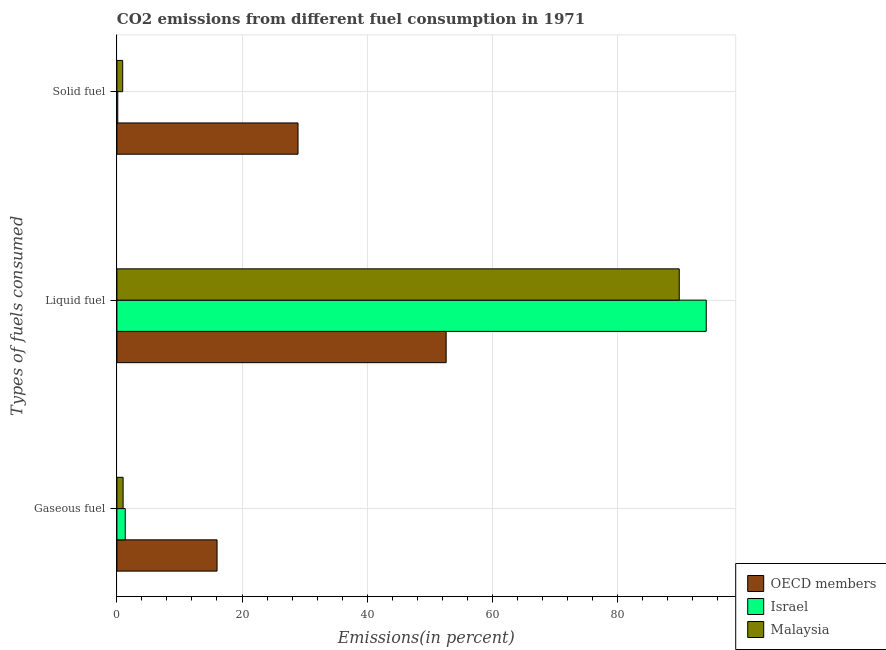How many different coloured bars are there?
Make the answer very short. 3. How many groups of bars are there?
Make the answer very short. 3. What is the label of the 3rd group of bars from the top?
Provide a short and direct response. Gaseous fuel. What is the percentage of gaseous fuel emission in Malaysia?
Keep it short and to the point. 0.99. Across all countries, what is the maximum percentage of gaseous fuel emission?
Ensure brevity in your answer.  16.01. Across all countries, what is the minimum percentage of gaseous fuel emission?
Offer a very short reply. 0.99. In which country was the percentage of liquid fuel emission maximum?
Give a very brief answer. Israel. In which country was the percentage of liquid fuel emission minimum?
Your answer should be very brief. OECD members. What is the total percentage of solid fuel emission in the graph?
Your answer should be compact. 30.01. What is the difference between the percentage of solid fuel emission in Malaysia and that in OECD members?
Provide a succinct answer. -28.03. What is the difference between the percentage of gaseous fuel emission in Malaysia and the percentage of solid fuel emission in Israel?
Ensure brevity in your answer.  0.85. What is the average percentage of liquid fuel emission per country?
Your response must be concise. 78.92. What is the difference between the percentage of solid fuel emission and percentage of liquid fuel emission in Malaysia?
Keep it short and to the point. -88.98. What is the ratio of the percentage of liquid fuel emission in Israel to that in Malaysia?
Your answer should be very brief. 1.05. Is the percentage of liquid fuel emission in OECD members less than that in Israel?
Ensure brevity in your answer.  Yes. Is the difference between the percentage of liquid fuel emission in OECD members and Israel greater than the difference between the percentage of gaseous fuel emission in OECD members and Israel?
Give a very brief answer. No. What is the difference between the highest and the second highest percentage of solid fuel emission?
Ensure brevity in your answer.  28.03. What is the difference between the highest and the lowest percentage of liquid fuel emission?
Your response must be concise. 41.58. In how many countries, is the percentage of solid fuel emission greater than the average percentage of solid fuel emission taken over all countries?
Give a very brief answer. 1. What does the 3rd bar from the bottom in Liquid fuel represents?
Your response must be concise. Malaysia. How many bars are there?
Your response must be concise. 9. Are all the bars in the graph horizontal?
Ensure brevity in your answer.  Yes. Are the values on the major ticks of X-axis written in scientific E-notation?
Offer a terse response. No. Does the graph contain any zero values?
Offer a very short reply. No. Does the graph contain grids?
Your answer should be compact. Yes. What is the title of the graph?
Make the answer very short. CO2 emissions from different fuel consumption in 1971. Does "Finland" appear as one of the legend labels in the graph?
Your answer should be very brief. No. What is the label or title of the X-axis?
Ensure brevity in your answer.  Emissions(in percent). What is the label or title of the Y-axis?
Offer a terse response. Types of fuels consumed. What is the Emissions(in percent) of OECD members in Gaseous fuel?
Your response must be concise. 16.01. What is the Emissions(in percent) in Israel in Gaseous fuel?
Offer a terse response. 1.33. What is the Emissions(in percent) of Malaysia in Gaseous fuel?
Provide a short and direct response. 0.99. What is the Emissions(in percent) of OECD members in Liquid fuel?
Offer a terse response. 52.64. What is the Emissions(in percent) of Israel in Liquid fuel?
Your answer should be very brief. 94.22. What is the Emissions(in percent) in Malaysia in Liquid fuel?
Offer a very short reply. 89.91. What is the Emissions(in percent) of OECD members in Solid fuel?
Your answer should be compact. 28.95. What is the Emissions(in percent) in Israel in Solid fuel?
Make the answer very short. 0.14. What is the Emissions(in percent) of Malaysia in Solid fuel?
Provide a short and direct response. 0.92. Across all Types of fuels consumed, what is the maximum Emissions(in percent) of OECD members?
Your answer should be compact. 52.64. Across all Types of fuels consumed, what is the maximum Emissions(in percent) in Israel?
Make the answer very short. 94.22. Across all Types of fuels consumed, what is the maximum Emissions(in percent) in Malaysia?
Your response must be concise. 89.91. Across all Types of fuels consumed, what is the minimum Emissions(in percent) in OECD members?
Keep it short and to the point. 16.01. Across all Types of fuels consumed, what is the minimum Emissions(in percent) of Israel?
Provide a succinct answer. 0.14. Across all Types of fuels consumed, what is the minimum Emissions(in percent) in Malaysia?
Ensure brevity in your answer.  0.92. What is the total Emissions(in percent) in OECD members in the graph?
Your response must be concise. 97.6. What is the total Emissions(in percent) of Israel in the graph?
Keep it short and to the point. 95.69. What is the total Emissions(in percent) of Malaysia in the graph?
Provide a short and direct response. 91.82. What is the difference between the Emissions(in percent) of OECD members in Gaseous fuel and that in Liquid fuel?
Your response must be concise. -36.63. What is the difference between the Emissions(in percent) in Israel in Gaseous fuel and that in Liquid fuel?
Make the answer very short. -92.89. What is the difference between the Emissions(in percent) of Malaysia in Gaseous fuel and that in Liquid fuel?
Provide a succinct answer. -88.92. What is the difference between the Emissions(in percent) in OECD members in Gaseous fuel and that in Solid fuel?
Offer a terse response. -12.95. What is the difference between the Emissions(in percent) of Israel in Gaseous fuel and that in Solid fuel?
Your response must be concise. 1.2. What is the difference between the Emissions(in percent) of Malaysia in Gaseous fuel and that in Solid fuel?
Make the answer very short. 0.07. What is the difference between the Emissions(in percent) in OECD members in Liquid fuel and that in Solid fuel?
Offer a terse response. 23.68. What is the difference between the Emissions(in percent) of Israel in Liquid fuel and that in Solid fuel?
Your response must be concise. 94.09. What is the difference between the Emissions(in percent) of Malaysia in Liquid fuel and that in Solid fuel?
Offer a terse response. 88.98. What is the difference between the Emissions(in percent) in OECD members in Gaseous fuel and the Emissions(in percent) in Israel in Liquid fuel?
Offer a terse response. -78.21. What is the difference between the Emissions(in percent) in OECD members in Gaseous fuel and the Emissions(in percent) in Malaysia in Liquid fuel?
Keep it short and to the point. -73.9. What is the difference between the Emissions(in percent) in Israel in Gaseous fuel and the Emissions(in percent) in Malaysia in Liquid fuel?
Provide a succinct answer. -88.58. What is the difference between the Emissions(in percent) in OECD members in Gaseous fuel and the Emissions(in percent) in Israel in Solid fuel?
Your answer should be very brief. 15.87. What is the difference between the Emissions(in percent) in OECD members in Gaseous fuel and the Emissions(in percent) in Malaysia in Solid fuel?
Make the answer very short. 15.09. What is the difference between the Emissions(in percent) in Israel in Gaseous fuel and the Emissions(in percent) in Malaysia in Solid fuel?
Keep it short and to the point. 0.41. What is the difference between the Emissions(in percent) in OECD members in Liquid fuel and the Emissions(in percent) in Israel in Solid fuel?
Offer a very short reply. 52.5. What is the difference between the Emissions(in percent) in OECD members in Liquid fuel and the Emissions(in percent) in Malaysia in Solid fuel?
Keep it short and to the point. 51.71. What is the difference between the Emissions(in percent) of Israel in Liquid fuel and the Emissions(in percent) of Malaysia in Solid fuel?
Provide a succinct answer. 93.3. What is the average Emissions(in percent) of OECD members per Types of fuels consumed?
Offer a very short reply. 32.53. What is the average Emissions(in percent) of Israel per Types of fuels consumed?
Provide a succinct answer. 31.9. What is the average Emissions(in percent) of Malaysia per Types of fuels consumed?
Your answer should be compact. 30.61. What is the difference between the Emissions(in percent) of OECD members and Emissions(in percent) of Israel in Gaseous fuel?
Offer a very short reply. 14.68. What is the difference between the Emissions(in percent) of OECD members and Emissions(in percent) of Malaysia in Gaseous fuel?
Provide a short and direct response. 15.02. What is the difference between the Emissions(in percent) in Israel and Emissions(in percent) in Malaysia in Gaseous fuel?
Offer a very short reply. 0.34. What is the difference between the Emissions(in percent) of OECD members and Emissions(in percent) of Israel in Liquid fuel?
Give a very brief answer. -41.58. What is the difference between the Emissions(in percent) in OECD members and Emissions(in percent) in Malaysia in Liquid fuel?
Your answer should be compact. -37.27. What is the difference between the Emissions(in percent) in Israel and Emissions(in percent) in Malaysia in Liquid fuel?
Give a very brief answer. 4.31. What is the difference between the Emissions(in percent) of OECD members and Emissions(in percent) of Israel in Solid fuel?
Ensure brevity in your answer.  28.82. What is the difference between the Emissions(in percent) in OECD members and Emissions(in percent) in Malaysia in Solid fuel?
Offer a terse response. 28.03. What is the difference between the Emissions(in percent) of Israel and Emissions(in percent) of Malaysia in Solid fuel?
Make the answer very short. -0.79. What is the ratio of the Emissions(in percent) of OECD members in Gaseous fuel to that in Liquid fuel?
Your response must be concise. 0.3. What is the ratio of the Emissions(in percent) in Israel in Gaseous fuel to that in Liquid fuel?
Make the answer very short. 0.01. What is the ratio of the Emissions(in percent) of Malaysia in Gaseous fuel to that in Liquid fuel?
Your answer should be compact. 0.01. What is the ratio of the Emissions(in percent) of OECD members in Gaseous fuel to that in Solid fuel?
Keep it short and to the point. 0.55. What is the ratio of the Emissions(in percent) in Israel in Gaseous fuel to that in Solid fuel?
Give a very brief answer. 9.83. What is the ratio of the Emissions(in percent) in Malaysia in Gaseous fuel to that in Solid fuel?
Provide a short and direct response. 1.07. What is the ratio of the Emissions(in percent) of OECD members in Liquid fuel to that in Solid fuel?
Keep it short and to the point. 1.82. What is the ratio of the Emissions(in percent) in Israel in Liquid fuel to that in Solid fuel?
Keep it short and to the point. 695.83. What is the ratio of the Emissions(in percent) in Malaysia in Liquid fuel to that in Solid fuel?
Offer a very short reply. 97.36. What is the difference between the highest and the second highest Emissions(in percent) in OECD members?
Your answer should be very brief. 23.68. What is the difference between the highest and the second highest Emissions(in percent) of Israel?
Offer a terse response. 92.89. What is the difference between the highest and the second highest Emissions(in percent) of Malaysia?
Offer a very short reply. 88.92. What is the difference between the highest and the lowest Emissions(in percent) of OECD members?
Your answer should be very brief. 36.63. What is the difference between the highest and the lowest Emissions(in percent) of Israel?
Offer a very short reply. 94.09. What is the difference between the highest and the lowest Emissions(in percent) in Malaysia?
Keep it short and to the point. 88.98. 